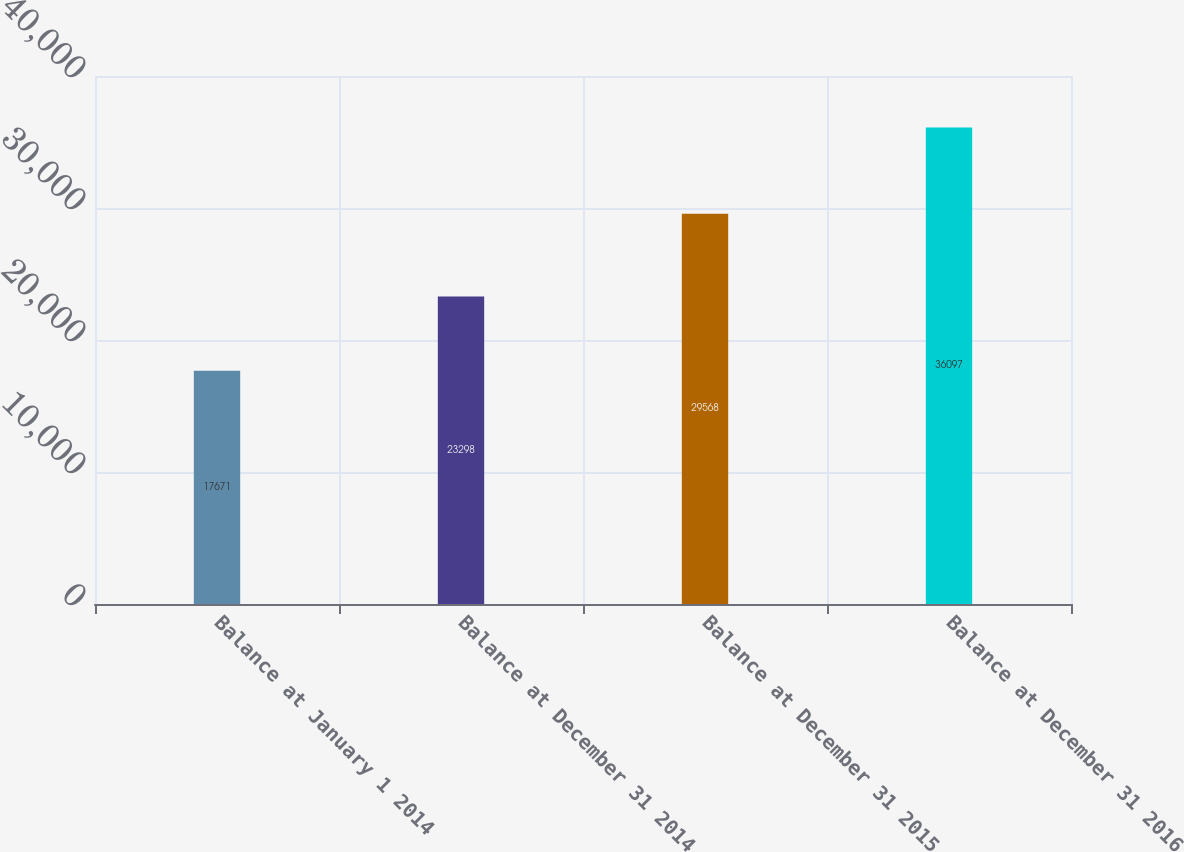<chart> <loc_0><loc_0><loc_500><loc_500><bar_chart><fcel>Balance at January 1 2014<fcel>Balance at December 31 2014<fcel>Balance at December 31 2015<fcel>Balance at December 31 2016<nl><fcel>17671<fcel>23298<fcel>29568<fcel>36097<nl></chart> 